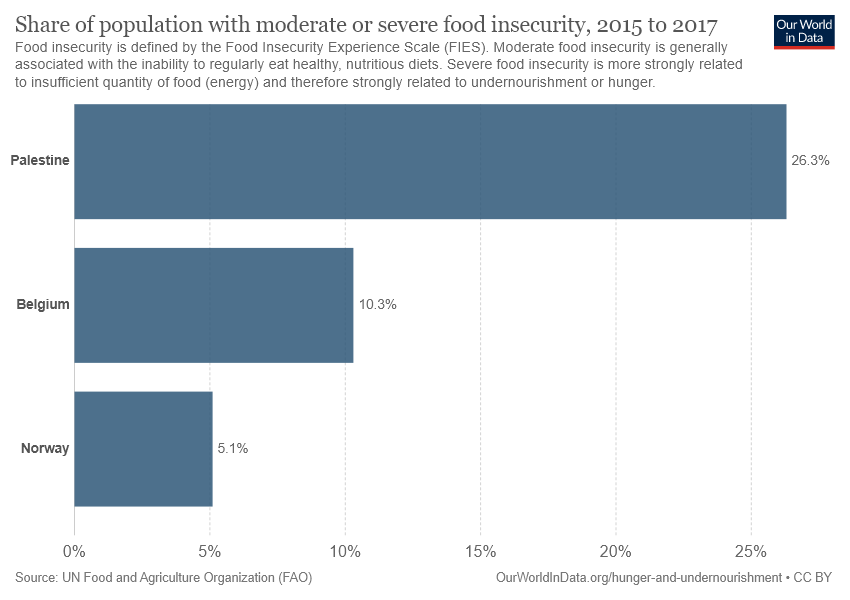Draw attention to some important aspects in this diagram. Palestine is represented by the longest bar in the country that is currently unknown. In the United States, the share of people experiencing maximum and minimum levels of food insecurity varies greatly, with 21.2% of the population experiencing maximum food insecurity and 3.3% experiencing minimum food insecurity in 2018. 